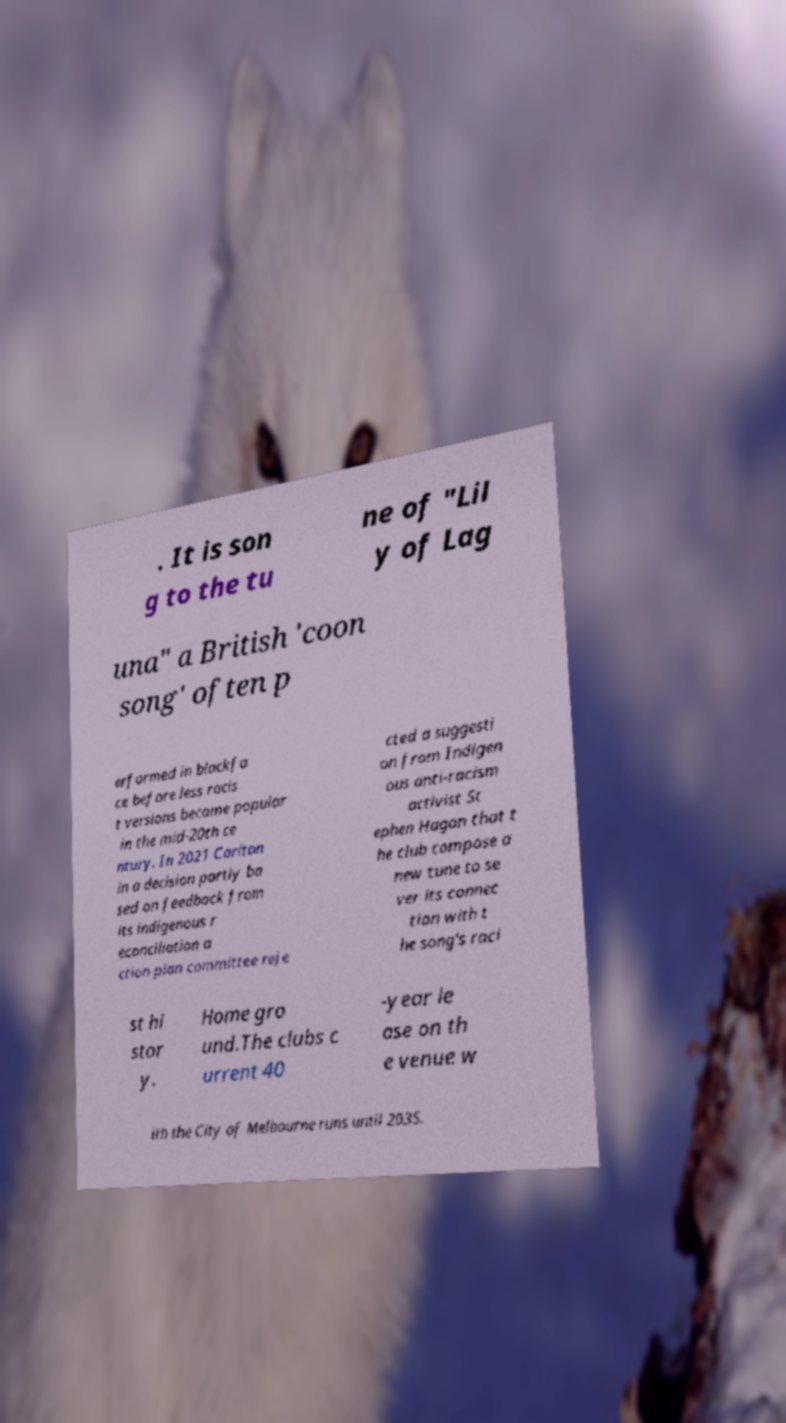Can you accurately transcribe the text from the provided image for me? . It is son g to the tu ne of "Lil y of Lag una" a British 'coon song' often p erformed in blackfa ce before less racis t versions became popular in the mid-20th ce ntury. In 2021 Carlton in a decision partly ba sed on feedback from its indigenous r econciliation a ction plan committee reje cted a suggesti on from Indigen ous anti-racism activist St ephen Hagan that t he club compose a new tune to se ver its connec tion with t he song's raci st hi stor y. Home gro und.The clubs c urrent 40 -year le ase on th e venue w ith the City of Melbourne runs until 2035. 